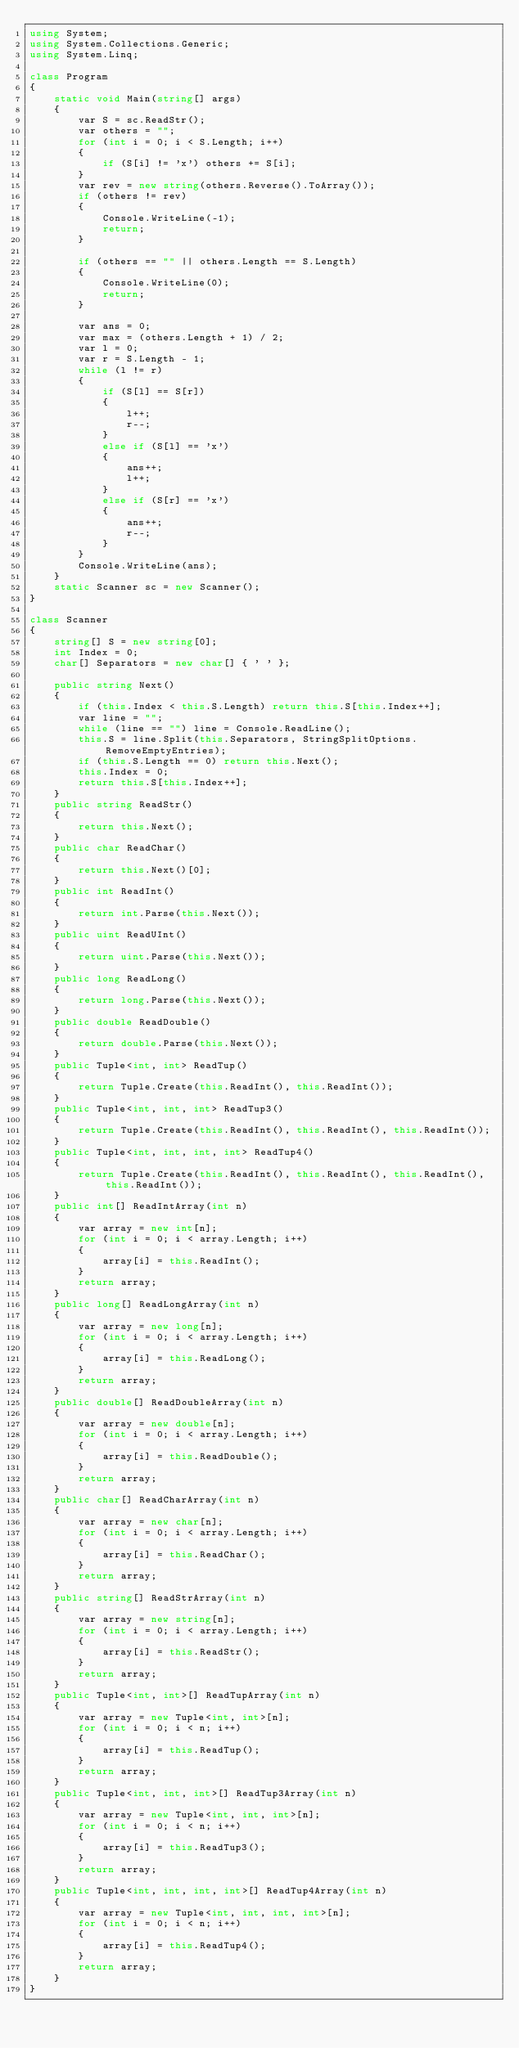<code> <loc_0><loc_0><loc_500><loc_500><_C#_>using System;
using System.Collections.Generic;
using System.Linq;

class Program
{
    static void Main(string[] args)
    {
        var S = sc.ReadStr();
        var others = "";
        for (int i = 0; i < S.Length; i++)
        {
            if (S[i] != 'x') others += S[i];
        }
        var rev = new string(others.Reverse().ToArray());
        if (others != rev)
        {
            Console.WriteLine(-1);
            return;
        }

        if (others == "" || others.Length == S.Length)
        {
            Console.WriteLine(0);
            return;
        }

        var ans = 0;
        var max = (others.Length + 1) / 2;
        var l = 0;
        var r = S.Length - 1;
        while (l != r)
        {
            if (S[l] == S[r])
            {
                l++;
                r--;
            }
            else if (S[l] == 'x')
            {
                ans++;
                l++;
            }
            else if (S[r] == 'x')
            {
                ans++;
                r--;
            }
        }
        Console.WriteLine(ans);
    }
    static Scanner sc = new Scanner();
}

class Scanner
{
    string[] S = new string[0];
    int Index = 0;
    char[] Separators = new char[] { ' ' };

    public string Next()
    {
        if (this.Index < this.S.Length) return this.S[this.Index++];
        var line = "";
        while (line == "") line = Console.ReadLine();
        this.S = line.Split(this.Separators, StringSplitOptions.RemoveEmptyEntries);
        if (this.S.Length == 0) return this.Next();
        this.Index = 0;
        return this.S[this.Index++];
    }
    public string ReadStr()
    {
        return this.Next();
    }
    public char ReadChar()
    {
        return this.Next()[0];
    }
    public int ReadInt()
    {
        return int.Parse(this.Next());
    }
    public uint ReadUInt()
    {
        return uint.Parse(this.Next());
    }
    public long ReadLong()
    {
        return long.Parse(this.Next());
    }
    public double ReadDouble()
    {
        return double.Parse(this.Next());
    }
    public Tuple<int, int> ReadTup()
    {
        return Tuple.Create(this.ReadInt(), this.ReadInt());
    }
    public Tuple<int, int, int> ReadTup3()
    {
        return Tuple.Create(this.ReadInt(), this.ReadInt(), this.ReadInt());
    }
    public Tuple<int, int, int, int> ReadTup4()
    {
        return Tuple.Create(this.ReadInt(), this.ReadInt(), this.ReadInt(), this.ReadInt());
    }
    public int[] ReadIntArray(int n)
    {
        var array = new int[n];
        for (int i = 0; i < array.Length; i++)
        {
            array[i] = this.ReadInt();
        }
        return array;
    }
    public long[] ReadLongArray(int n)
    {
        var array = new long[n];
        for (int i = 0; i < array.Length; i++)
        {
            array[i] = this.ReadLong();
        }
        return array;
    }
    public double[] ReadDoubleArray(int n)
    {
        var array = new double[n];
        for (int i = 0; i < array.Length; i++)
        {
            array[i] = this.ReadDouble();
        }
        return array;
    }
    public char[] ReadCharArray(int n)
    {
        var array = new char[n];
        for (int i = 0; i < array.Length; i++)
        {
            array[i] = this.ReadChar();
        }
        return array;
    }
    public string[] ReadStrArray(int n)
    {
        var array = new string[n];
        for (int i = 0; i < array.Length; i++)
        {
            array[i] = this.ReadStr();
        }
        return array;
    }
    public Tuple<int, int>[] ReadTupArray(int n)
    {
        var array = new Tuple<int, int>[n];
        for (int i = 0; i < n; i++)
        {
            array[i] = this.ReadTup();
        }
        return array;
    }
    public Tuple<int, int, int>[] ReadTup3Array(int n)
    {
        var array = new Tuple<int, int, int>[n];
        for (int i = 0; i < n; i++)
        {
            array[i] = this.ReadTup3();
        }
        return array;
    }
    public Tuple<int, int, int, int>[] ReadTup4Array(int n)
    {
        var array = new Tuple<int, int, int, int>[n];
        for (int i = 0; i < n; i++)
        {
            array[i] = this.ReadTup4();
        }
        return array;
    }
}
</code> 